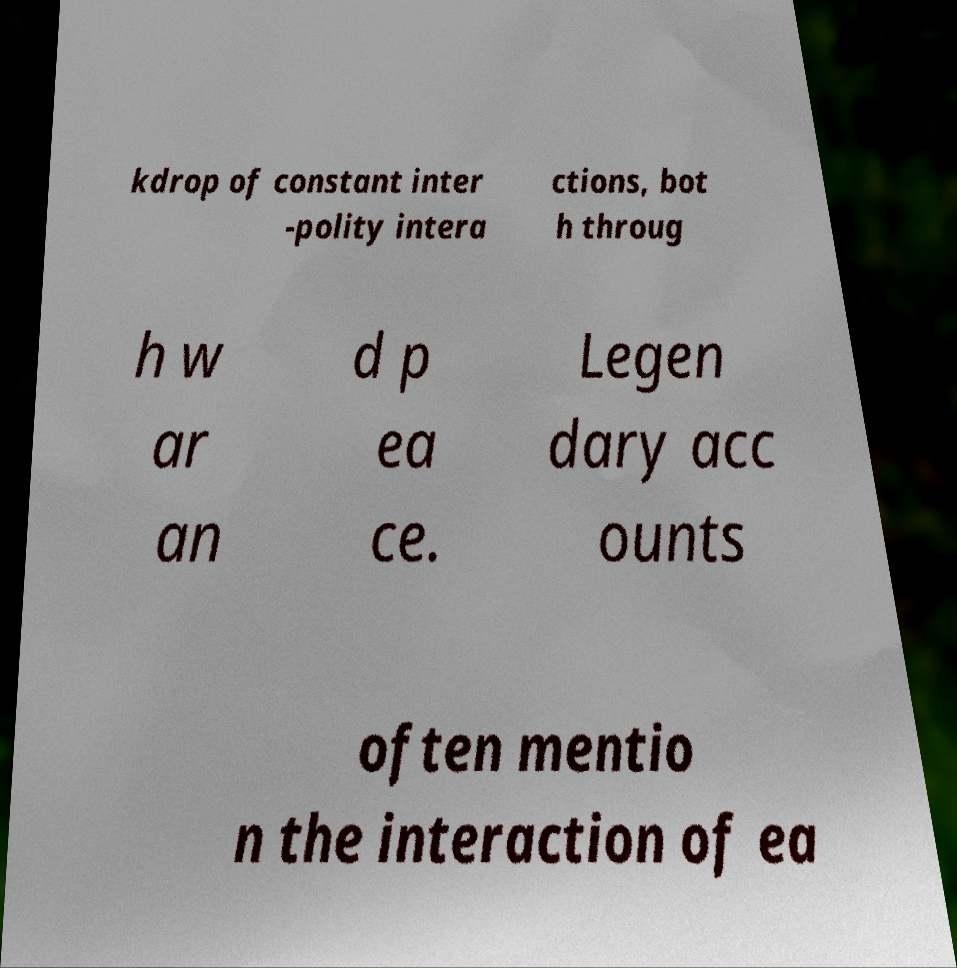Can you read and provide the text displayed in the image?This photo seems to have some interesting text. Can you extract and type it out for me? kdrop of constant inter -polity intera ctions, bot h throug h w ar an d p ea ce. Legen dary acc ounts often mentio n the interaction of ea 